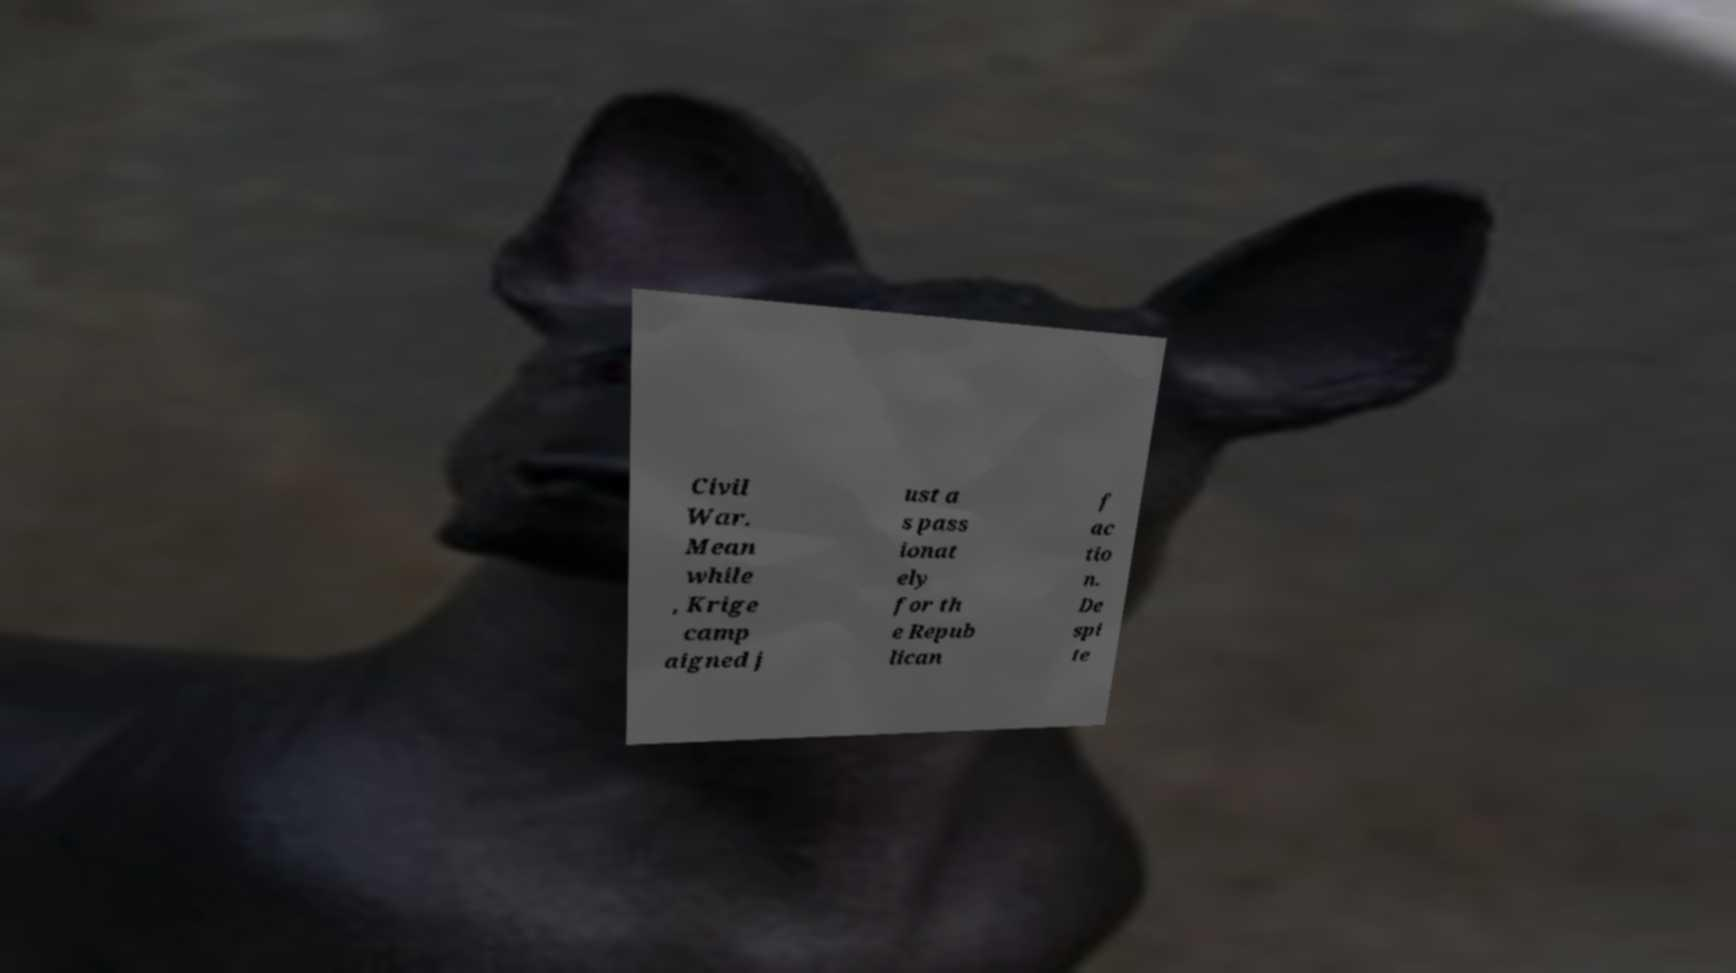Could you extract and type out the text from this image? Civil War. Mean while , Krige camp aigned j ust a s pass ionat ely for th e Repub lican f ac tio n. De spi te 